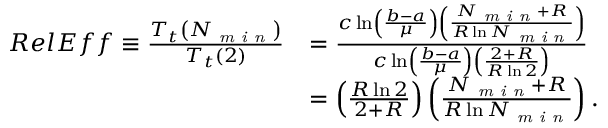<formula> <loc_0><loc_0><loc_500><loc_500>\begin{array} { r l } { R e l E f f \equiv \frac { T _ { t } \left ( N _ { \min } \right ) } { T _ { t } \left ( 2 \right ) } } & { = \frac { c \ln \left ( \frac { b - a } { \mu } \right ) \left ( \frac { N _ { \min } + R } { R \ln N _ { \min } } \right ) } { c \ln \left ( \frac { b - a } { \mu } \right ) \left ( \frac { 2 + R } { R \ln 2 } \right ) } } \\ & { = \left ( \frac { R \ln 2 } { 2 + R } \right ) \left ( \frac { N _ { \min } + R } { R \ln N _ { \min } } \right ) . } \end{array}</formula> 